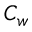<formula> <loc_0><loc_0><loc_500><loc_500>C _ { w }</formula> 